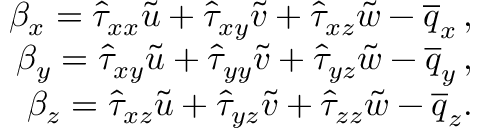<formula> <loc_0><loc_0><loc_500><loc_500>\begin{array} { r } { \beta _ { x } = \hat { \tau } _ { x x } \tilde { u } + \hat { \tau } _ { x y } \tilde { v } + \hat { \tau } _ { x z } \tilde { w } - \overline { q } _ { x } \, , } \\ { \beta _ { y } = \hat { \tau } _ { x y } \tilde { u } + \hat { \tau } _ { y y } \tilde { v } + \hat { \tau } _ { y z } \tilde { w } - \overline { q } _ { y } \, , } \\ { \beta _ { z } = \hat { \tau } _ { x z } \tilde { u } + \hat { \tau } _ { y z } \tilde { v } + \hat { \tau } _ { z z } \tilde { w } - \overline { q } _ { z } . } \end{array}</formula> 